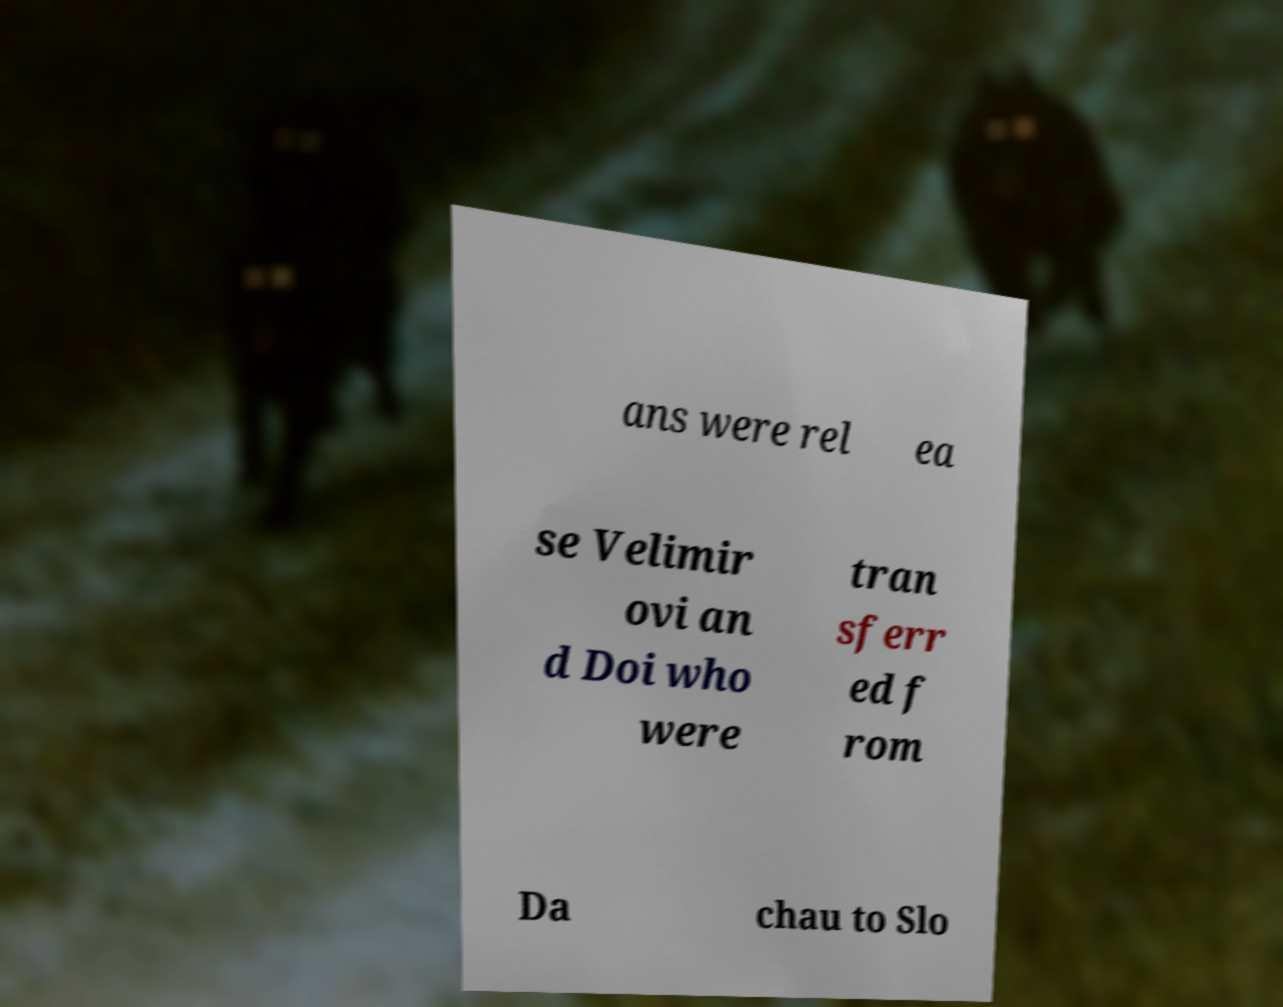Can you accurately transcribe the text from the provided image for me? ans were rel ea se Velimir ovi an d Doi who were tran sferr ed f rom Da chau to Slo 